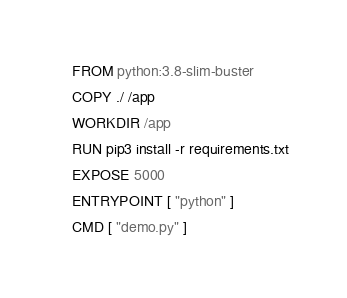Convert code to text. <code><loc_0><loc_0><loc_500><loc_500><_Dockerfile_>FROM python:3.8-slim-buster
COPY ./ /app
WORKDIR /app
RUN pip3 install -r requirements.txt
EXPOSE 5000
ENTRYPOINT [ "python" ]
CMD [ "demo.py" ]
</code> 